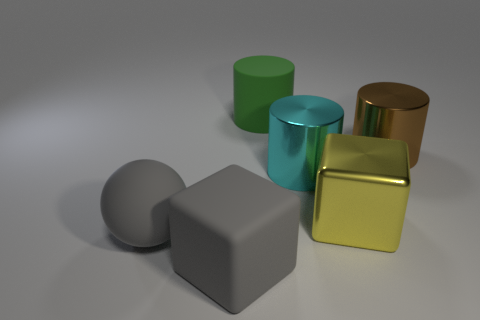What color is the cylinder that is made of the same material as the sphere?
Offer a very short reply. Green. Do the cyan thing and the large green rubber object have the same shape?
Your answer should be compact. Yes. There is a big block that is in front of the thing to the left of the matte cube; are there any matte cylinders behind it?
Keep it short and to the point. Yes. What number of balls are the same color as the large matte cube?
Your answer should be compact. 1. There is a cyan shiny thing that is the same size as the yellow block; what is its shape?
Ensure brevity in your answer.  Cylinder. Are there any large gray matte cubes to the left of the big matte sphere?
Keep it short and to the point. No. Do the green object and the yellow metal thing have the same size?
Provide a succinct answer. Yes. There is a big thing right of the big shiny cube; what is its shape?
Your answer should be very brief. Cylinder. Is there a metallic block that has the same size as the yellow metallic thing?
Give a very brief answer. No. What is the material of the yellow block that is the same size as the cyan cylinder?
Your response must be concise. Metal. 